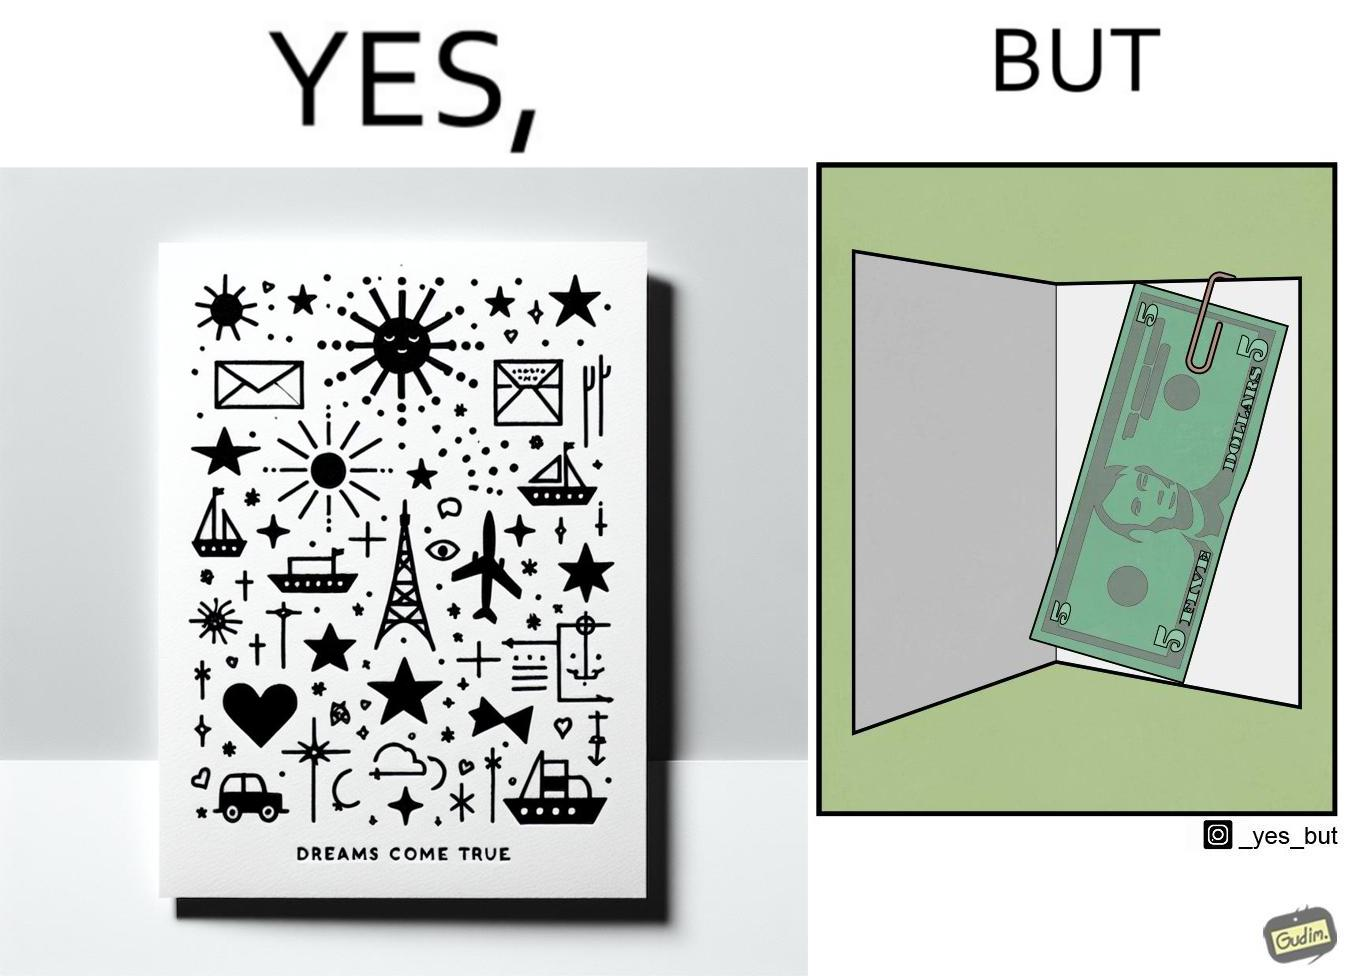Describe the satirical element in this image. The overall image is funny because while the front of the card gives hope that the person receiving this card will have one of their dreams come true but opening the card reveals only 5 dollars which is nowhere enough to fulfil any kind of dream. 